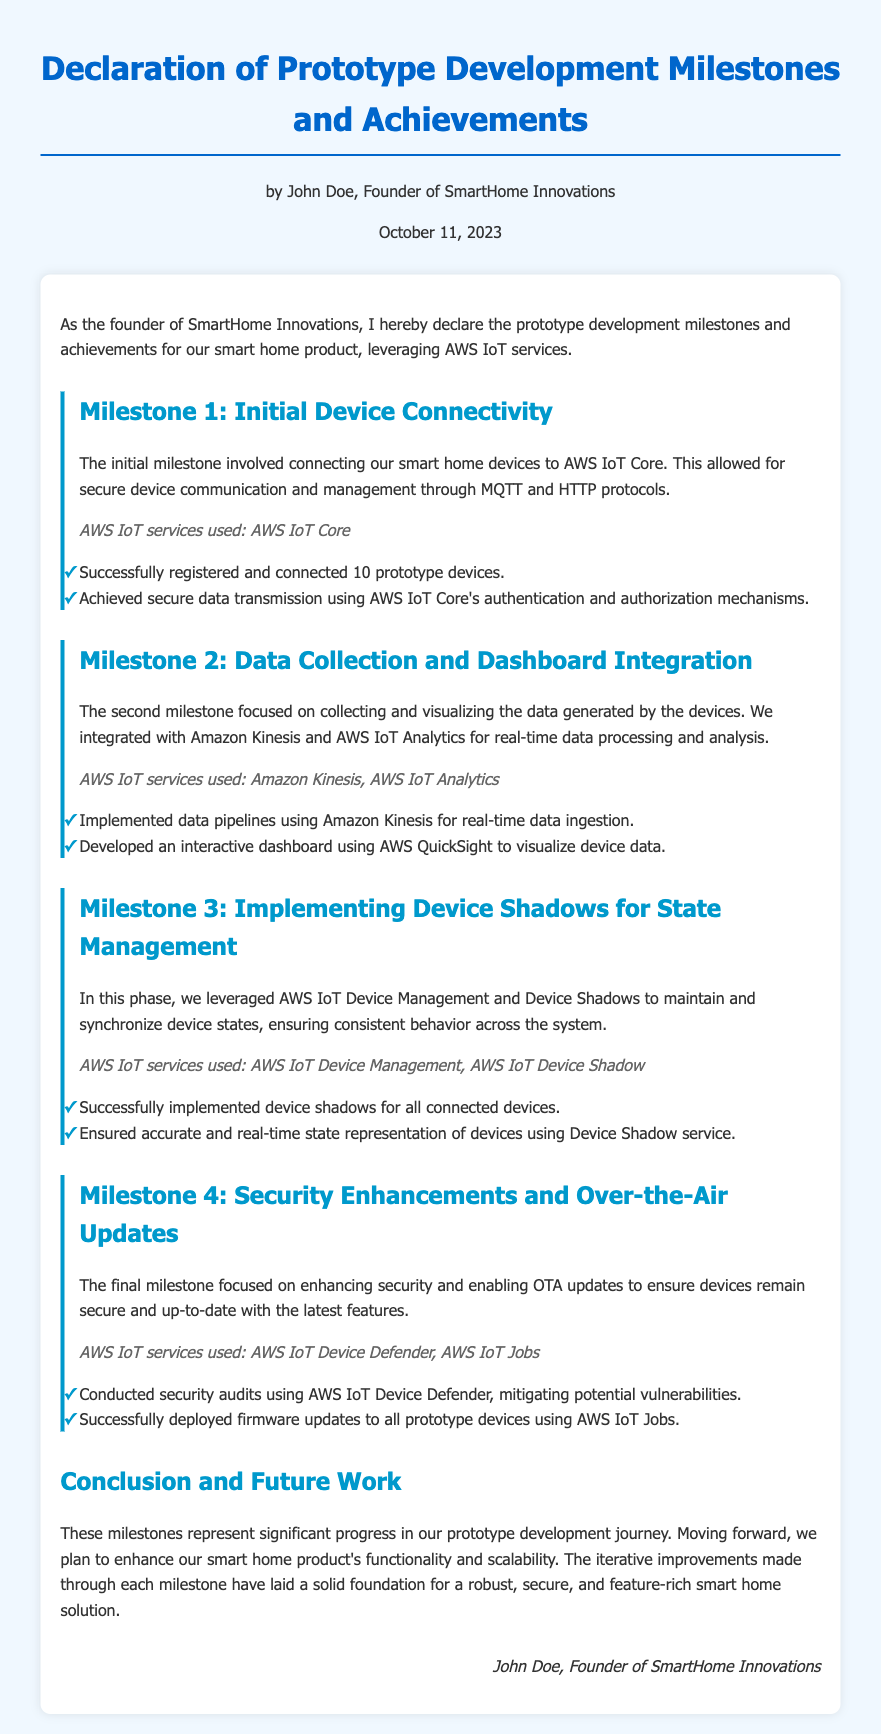What is the name of the founder? The founder's name is mentioned in the document's introduction, which states that it's by John Doe.
Answer: John Doe What date was the declaration made? The date is specified in the header of the document as October 11, 2023.
Answer: October 11, 2023 How many prototype devices were successfully registered? The number of successfully registered prototype devices is noted in Milestone 1, which states that 10 devices were connected.
Answer: 10 Which AWS IoT service was used for data visualization? The service used for data visualization is indicated in Milestone 2, where AWS QuickSight is mentioned as the tool for the dashboard.
Answer: AWS QuickSight What was accomplished using AWS IoT Device Defender? The document states that security audits were conducted using AWS IoT Device Defender to mitigate vulnerabilities.
Answer: Security audits What was the focus of Milestone 4? The focus of Milestone 4 can be inferred from the title and content, highlighting security enhancements and OTA updates.
Answer: Security enhancements and OTA updates Which AWS service was utilized for real-time data ingestion? The document specifies in Milestone 2 that Amazon Kinesis was implemented for real-time data ingestion.
Answer: Amazon Kinesis How many milestones are documented? The document lists four distinct milestones outlining the prototype development.
Answer: Four What future plans are mentioned in the document? The document concludes with plans to enhance the smart home product's functionality and scalability.
Answer: Enhance functionality and scalability 